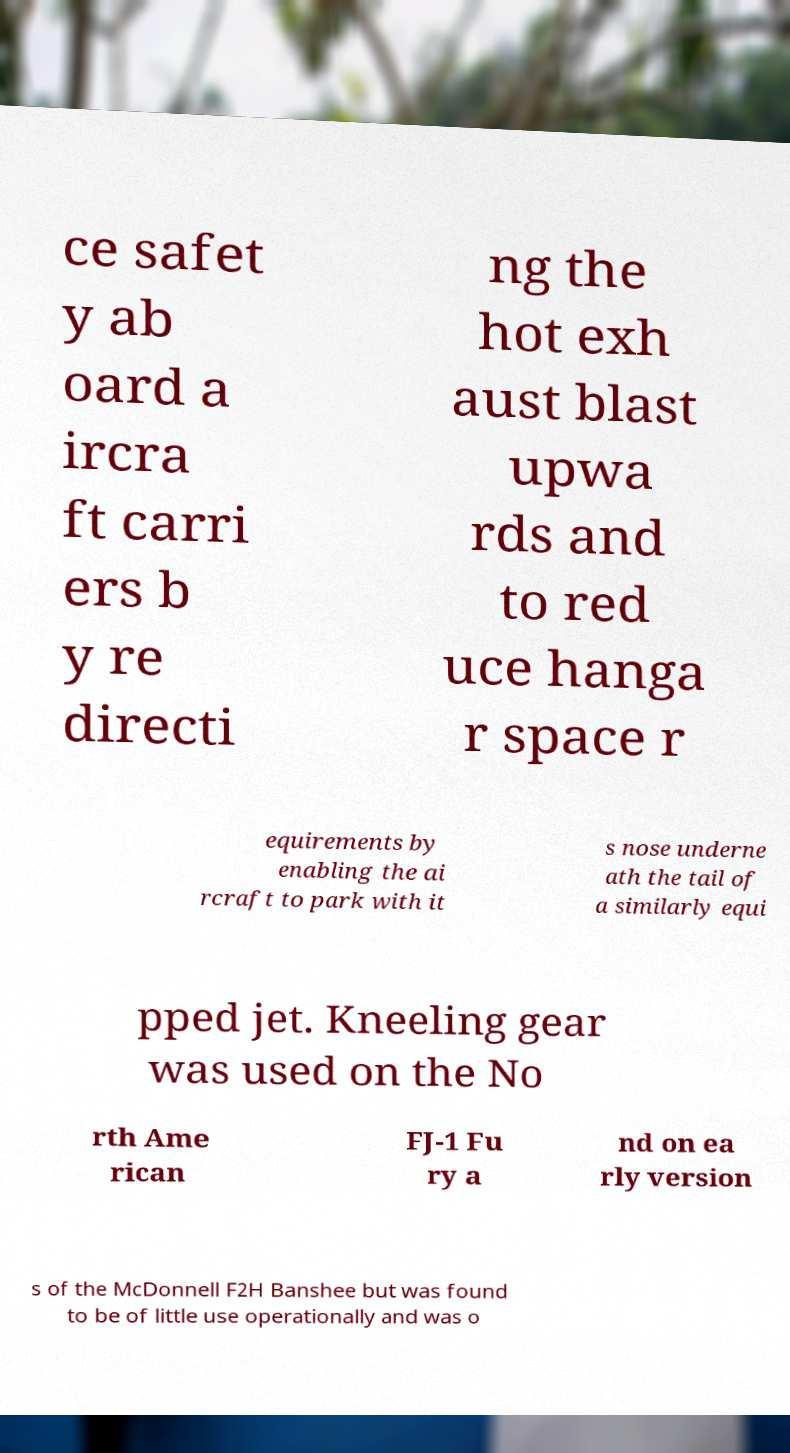Please read and relay the text visible in this image. What does it say? ce safet y ab oard a ircra ft carri ers b y re directi ng the hot exh aust blast upwa rds and to red uce hanga r space r equirements by enabling the ai rcraft to park with it s nose underne ath the tail of a similarly equi pped jet. Kneeling gear was used on the No rth Ame rican FJ-1 Fu ry a nd on ea rly version s of the McDonnell F2H Banshee but was found to be of little use operationally and was o 